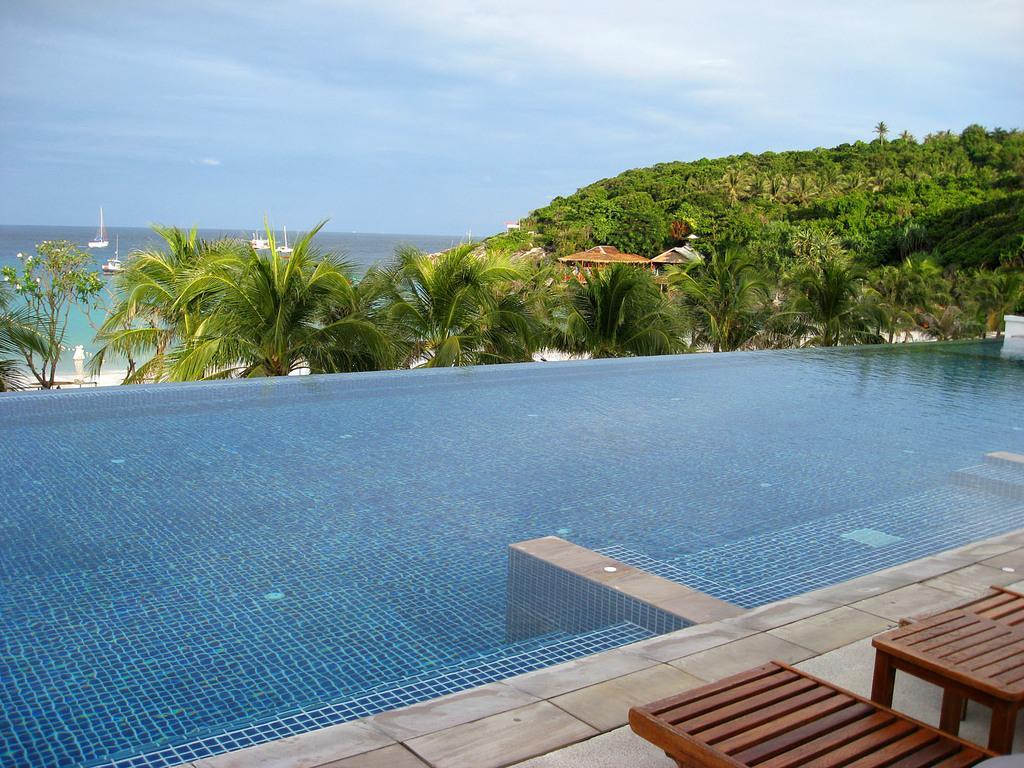How would you summarize this image in a sentence or two? In this image I can see the table and benches. To the side of these I can see the water. In the background I can see the trees, huts and few boats on the water. I can also see the sky in the back. 